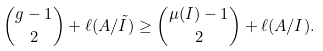<formula> <loc_0><loc_0><loc_500><loc_500>\binom { g - 1 } { 2 } + \ell ( A / \tilde { I } ) \geq \binom { \mu ( I ) - 1 } { 2 } + \ell ( A / I ) .</formula> 